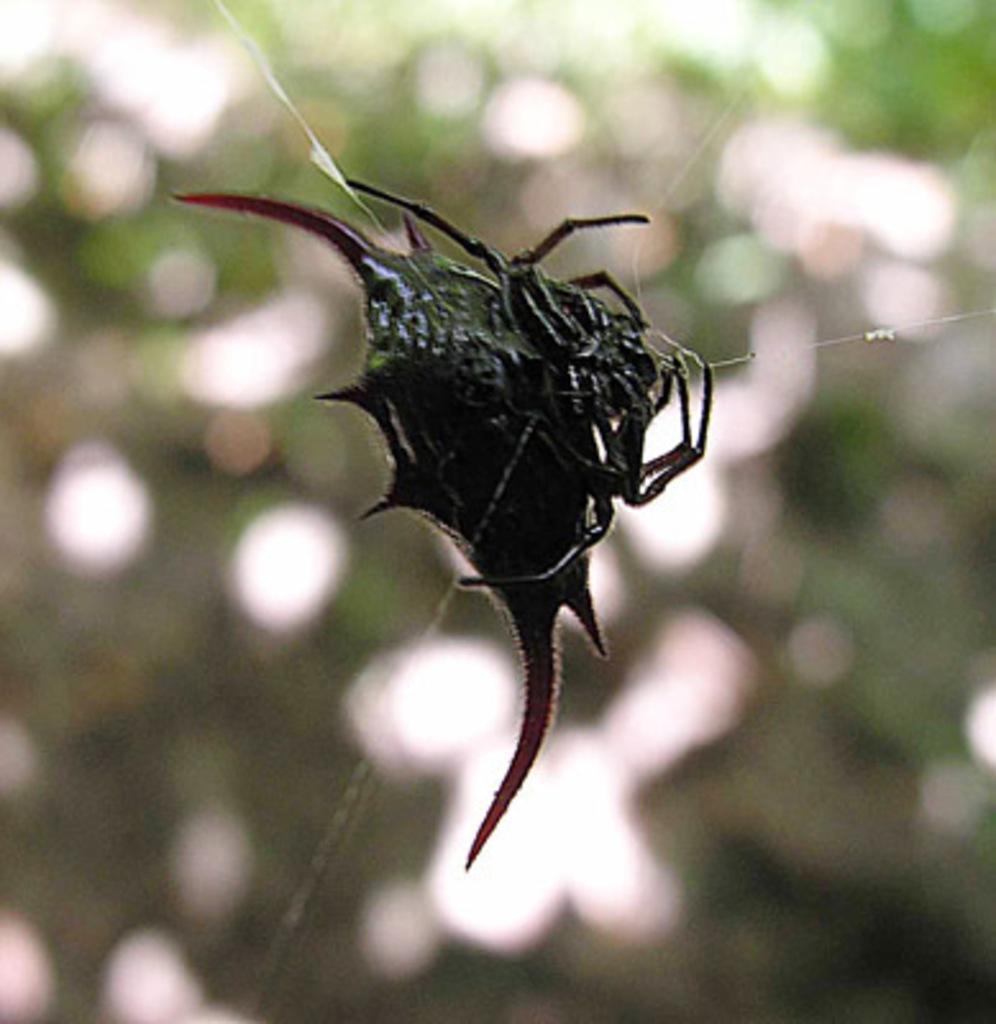In one or two sentences, can you explain what this image depicts? In this image I can see an insect which is in black color and there is a blurred background. 